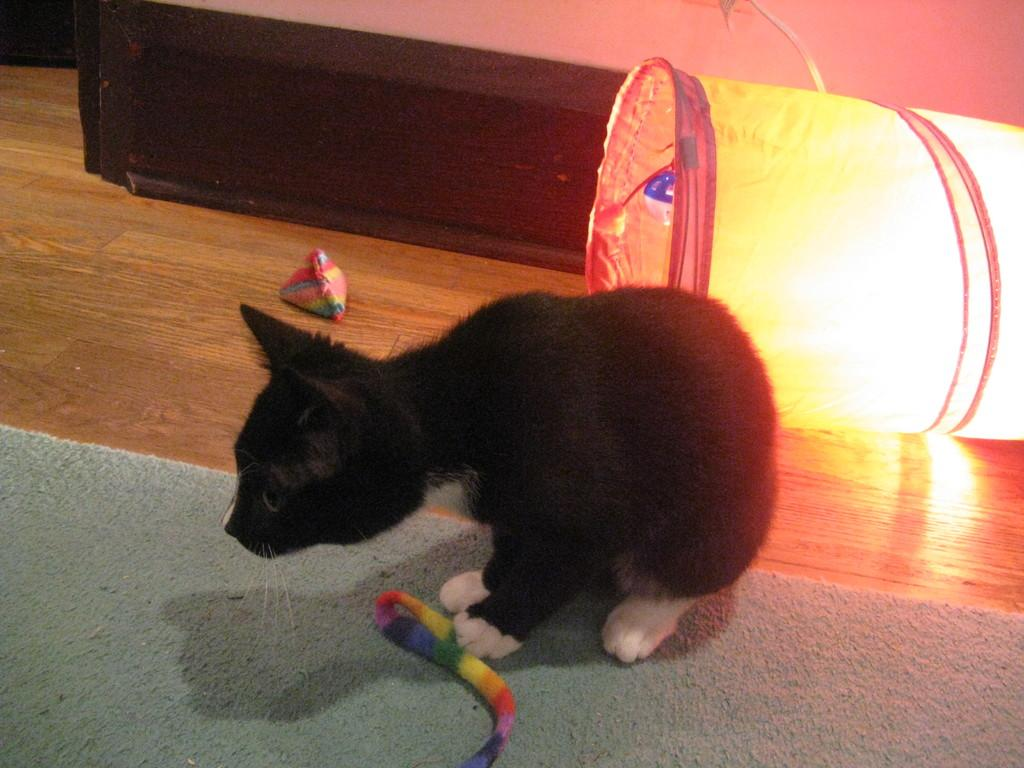What type of animal is in the image? There is an animal in the image, but the specific type cannot be determined from the provided facts. What is on the floor in the image? There is a mat on the floor and an object on the mat in the image. What is on the mat in the image? There is an object on the mat in the image. What is at the right side of the image? There is a lamp at the right side of the image. What card is the team using to hook the animal in the image? There is no card, team, or hook present in the image. 